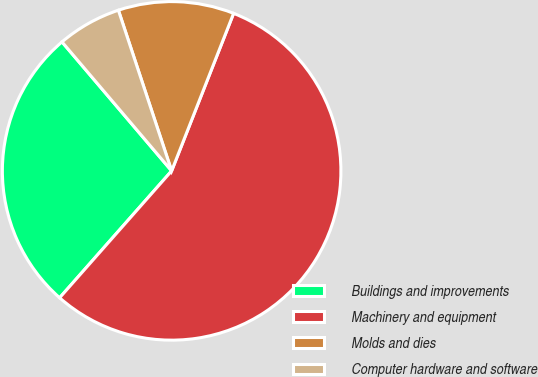<chart> <loc_0><loc_0><loc_500><loc_500><pie_chart><fcel>Buildings and improvements<fcel>Machinery and equipment<fcel>Molds and dies<fcel>Computer hardware and software<nl><fcel>27.28%<fcel>55.55%<fcel>11.06%<fcel>6.12%<nl></chart> 